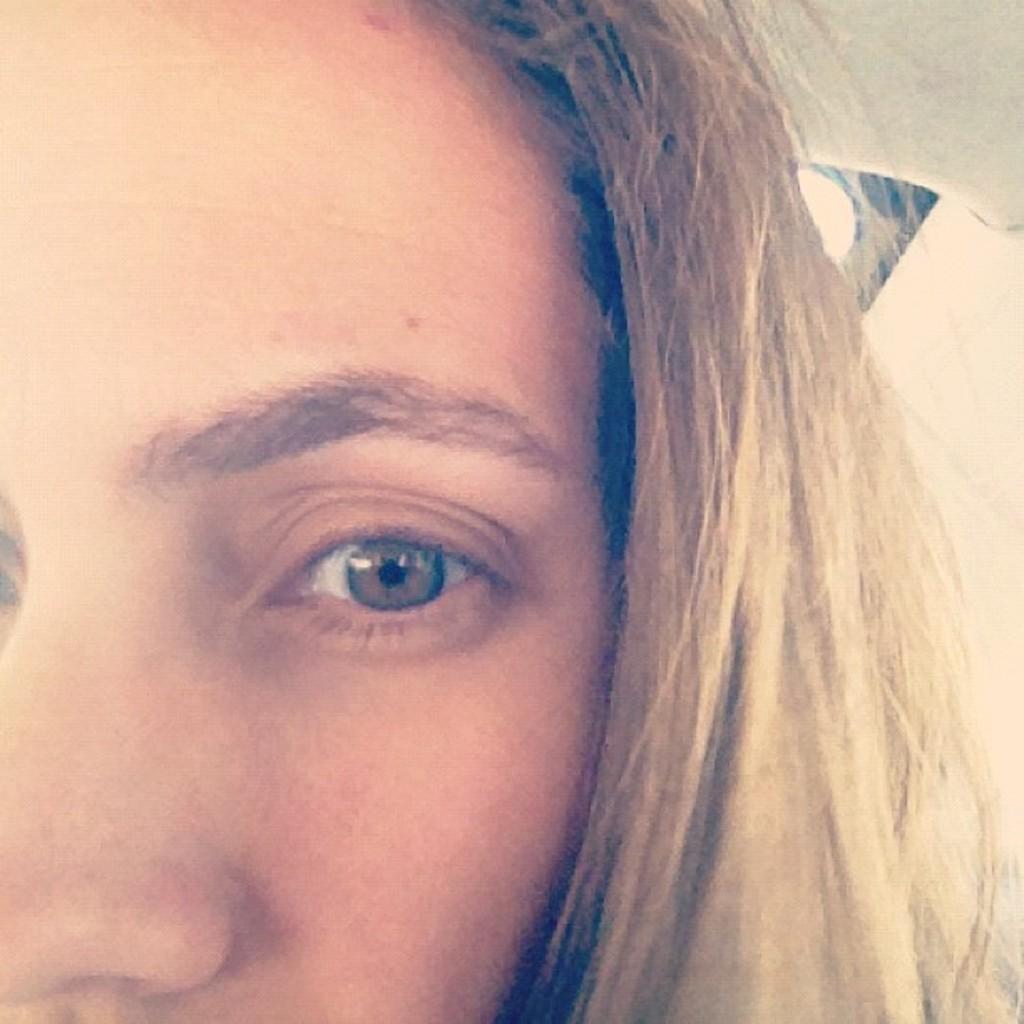How would you summarize this image in a sentence or two? In this image we can see half face of a girl. 